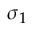Convert formula to latex. <formula><loc_0><loc_0><loc_500><loc_500>\sigma _ { 1 }</formula> 